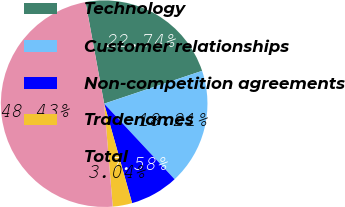Convert chart to OTSL. <chart><loc_0><loc_0><loc_500><loc_500><pie_chart><fcel>Technology<fcel>Customer relationships<fcel>Non-competition agreements<fcel>Tradenames<fcel>Total<nl><fcel>22.74%<fcel>18.21%<fcel>7.58%<fcel>3.04%<fcel>48.43%<nl></chart> 